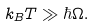<formula> <loc_0><loc_0><loc_500><loc_500>k _ { B } T \gg \hbar { \Omega } .</formula> 